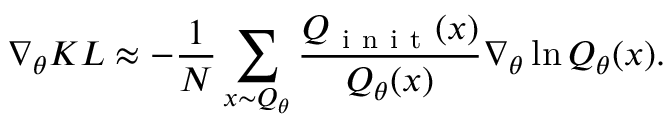Convert formula to latex. <formula><loc_0><loc_0><loc_500><loc_500>\nabla _ { \theta } K L \approx - \frac { 1 } { N } \sum _ { x \sim Q _ { \theta } } \frac { Q _ { i n i t } ( x ) } { Q _ { \theta } ( x ) } \nabla _ { \theta } \ln Q _ { \theta } ( x ) .</formula> 